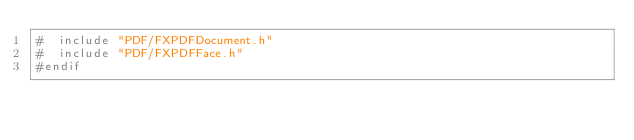<code> <loc_0><loc_0><loc_500><loc_500><_C_>#  include "PDF/FXPDFDocument.h"
#  include "PDF/FXPDFFace.h"
#endif
</code> 